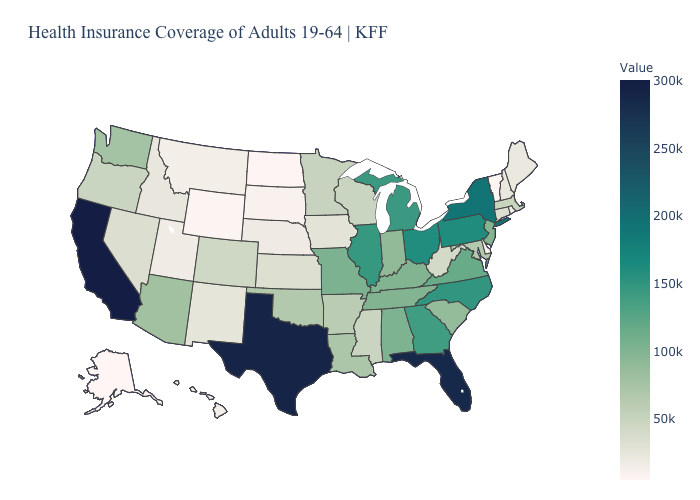Does Vermont have the lowest value in the Northeast?
Keep it brief. Yes. Does Mississippi have the lowest value in the USA?
Keep it brief. No. Among the states that border Montana , does Idaho have the highest value?
Keep it brief. Yes. Among the states that border Rhode Island , does Connecticut have the highest value?
Be succinct. No. Does Maine have the lowest value in the USA?
Give a very brief answer. No. 